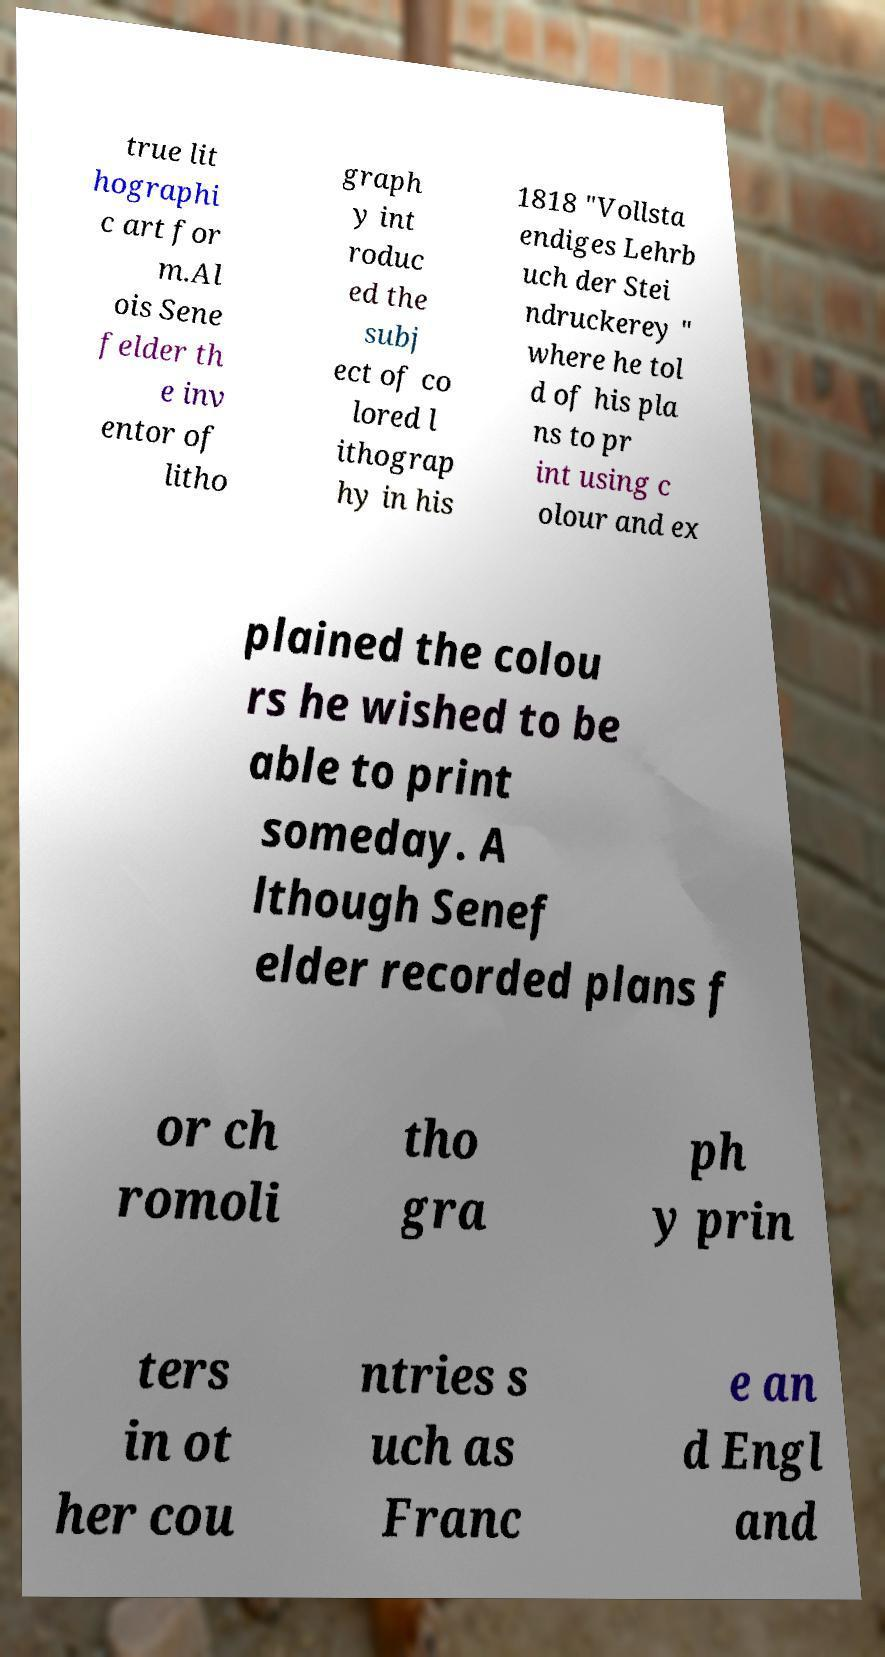Can you read and provide the text displayed in the image?This photo seems to have some interesting text. Can you extract and type it out for me? true lit hographi c art for m.Al ois Sene felder th e inv entor of litho graph y int roduc ed the subj ect of co lored l ithograp hy in his 1818 "Vollsta endiges Lehrb uch der Stei ndruckerey " where he tol d of his pla ns to pr int using c olour and ex plained the colou rs he wished to be able to print someday. A lthough Senef elder recorded plans f or ch romoli tho gra ph y prin ters in ot her cou ntries s uch as Franc e an d Engl and 